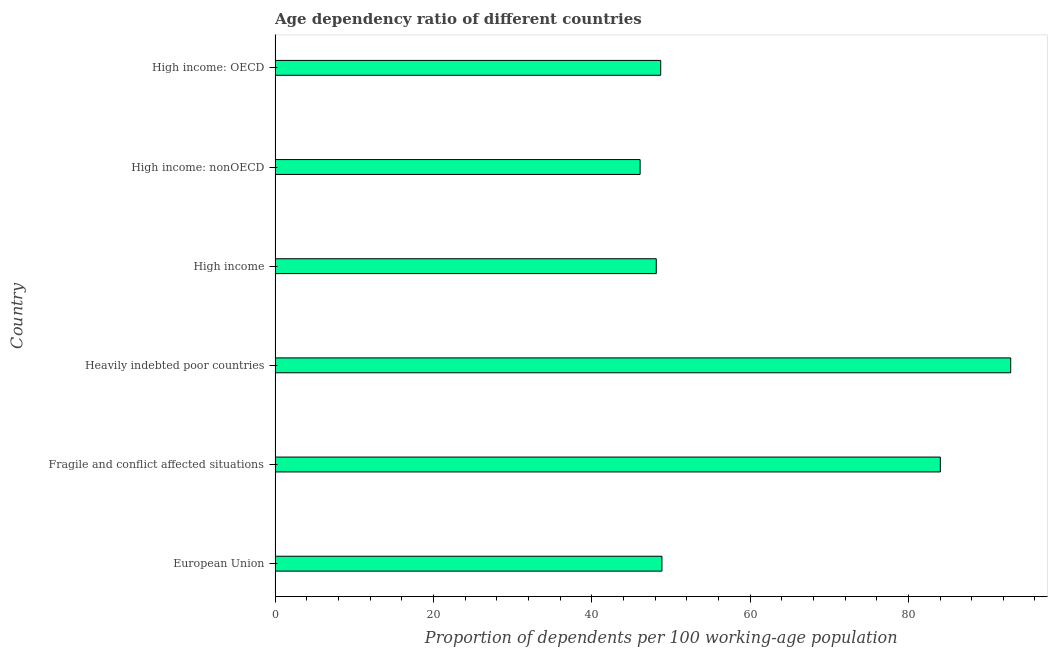Does the graph contain any zero values?
Make the answer very short. No. What is the title of the graph?
Provide a succinct answer. Age dependency ratio of different countries. What is the label or title of the X-axis?
Your answer should be very brief. Proportion of dependents per 100 working-age population. What is the label or title of the Y-axis?
Give a very brief answer. Country. What is the age dependency ratio in European Union?
Your answer should be compact. 48.87. Across all countries, what is the maximum age dependency ratio?
Make the answer very short. 92.93. Across all countries, what is the minimum age dependency ratio?
Make the answer very short. 46.12. In which country was the age dependency ratio maximum?
Keep it short and to the point. Heavily indebted poor countries. In which country was the age dependency ratio minimum?
Provide a short and direct response. High income: nonOECD. What is the sum of the age dependency ratio?
Ensure brevity in your answer.  368.84. What is the difference between the age dependency ratio in Fragile and conflict affected situations and High income?
Make the answer very short. 35.89. What is the average age dependency ratio per country?
Your answer should be compact. 61.47. What is the median age dependency ratio?
Ensure brevity in your answer.  48.79. What is the ratio of the age dependency ratio in European Union to that in Fragile and conflict affected situations?
Your response must be concise. 0.58. Is the age dependency ratio in High income: OECD less than that in High income: nonOECD?
Give a very brief answer. No. What is the difference between the highest and the second highest age dependency ratio?
Give a very brief answer. 8.89. Is the sum of the age dependency ratio in Fragile and conflict affected situations and High income greater than the maximum age dependency ratio across all countries?
Make the answer very short. Yes. What is the difference between the highest and the lowest age dependency ratio?
Provide a succinct answer. 46.82. Are all the bars in the graph horizontal?
Your answer should be compact. Yes. Are the values on the major ticks of X-axis written in scientific E-notation?
Provide a succinct answer. No. What is the Proportion of dependents per 100 working-age population of European Union?
Your answer should be very brief. 48.87. What is the Proportion of dependents per 100 working-age population of Fragile and conflict affected situations?
Give a very brief answer. 84.04. What is the Proportion of dependents per 100 working-age population of Heavily indebted poor countries?
Give a very brief answer. 92.93. What is the Proportion of dependents per 100 working-age population in High income?
Offer a terse response. 48.16. What is the Proportion of dependents per 100 working-age population in High income: nonOECD?
Make the answer very short. 46.12. What is the Proportion of dependents per 100 working-age population of High income: OECD?
Provide a short and direct response. 48.72. What is the difference between the Proportion of dependents per 100 working-age population in European Union and Fragile and conflict affected situations?
Keep it short and to the point. -35.17. What is the difference between the Proportion of dependents per 100 working-age population in European Union and Heavily indebted poor countries?
Offer a terse response. -44.06. What is the difference between the Proportion of dependents per 100 working-age population in European Union and High income?
Offer a terse response. 0.72. What is the difference between the Proportion of dependents per 100 working-age population in European Union and High income: nonOECD?
Offer a terse response. 2.76. What is the difference between the Proportion of dependents per 100 working-age population in European Union and High income: OECD?
Your response must be concise. 0.16. What is the difference between the Proportion of dependents per 100 working-age population in Fragile and conflict affected situations and Heavily indebted poor countries?
Make the answer very short. -8.89. What is the difference between the Proportion of dependents per 100 working-age population in Fragile and conflict affected situations and High income?
Offer a very short reply. 35.89. What is the difference between the Proportion of dependents per 100 working-age population in Fragile and conflict affected situations and High income: nonOECD?
Offer a very short reply. 37.93. What is the difference between the Proportion of dependents per 100 working-age population in Fragile and conflict affected situations and High income: OECD?
Give a very brief answer. 35.33. What is the difference between the Proportion of dependents per 100 working-age population in Heavily indebted poor countries and High income?
Offer a very short reply. 44.78. What is the difference between the Proportion of dependents per 100 working-age population in Heavily indebted poor countries and High income: nonOECD?
Your answer should be compact. 46.82. What is the difference between the Proportion of dependents per 100 working-age population in Heavily indebted poor countries and High income: OECD?
Offer a very short reply. 44.22. What is the difference between the Proportion of dependents per 100 working-age population in High income and High income: nonOECD?
Offer a terse response. 2.04. What is the difference between the Proportion of dependents per 100 working-age population in High income and High income: OECD?
Offer a terse response. -0.56. What is the difference between the Proportion of dependents per 100 working-age population in High income: nonOECD and High income: OECD?
Ensure brevity in your answer.  -2.6. What is the ratio of the Proportion of dependents per 100 working-age population in European Union to that in Fragile and conflict affected situations?
Make the answer very short. 0.58. What is the ratio of the Proportion of dependents per 100 working-age population in European Union to that in Heavily indebted poor countries?
Keep it short and to the point. 0.53. What is the ratio of the Proportion of dependents per 100 working-age population in European Union to that in High income: nonOECD?
Your answer should be very brief. 1.06. What is the ratio of the Proportion of dependents per 100 working-age population in European Union to that in High income: OECD?
Your response must be concise. 1. What is the ratio of the Proportion of dependents per 100 working-age population in Fragile and conflict affected situations to that in Heavily indebted poor countries?
Your answer should be very brief. 0.9. What is the ratio of the Proportion of dependents per 100 working-age population in Fragile and conflict affected situations to that in High income?
Ensure brevity in your answer.  1.75. What is the ratio of the Proportion of dependents per 100 working-age population in Fragile and conflict affected situations to that in High income: nonOECD?
Ensure brevity in your answer.  1.82. What is the ratio of the Proportion of dependents per 100 working-age population in Fragile and conflict affected situations to that in High income: OECD?
Ensure brevity in your answer.  1.73. What is the ratio of the Proportion of dependents per 100 working-age population in Heavily indebted poor countries to that in High income?
Provide a succinct answer. 1.93. What is the ratio of the Proportion of dependents per 100 working-age population in Heavily indebted poor countries to that in High income: nonOECD?
Provide a succinct answer. 2.02. What is the ratio of the Proportion of dependents per 100 working-age population in Heavily indebted poor countries to that in High income: OECD?
Your answer should be compact. 1.91. What is the ratio of the Proportion of dependents per 100 working-age population in High income to that in High income: nonOECD?
Your answer should be compact. 1.04. What is the ratio of the Proportion of dependents per 100 working-age population in High income to that in High income: OECD?
Make the answer very short. 0.99. What is the ratio of the Proportion of dependents per 100 working-age population in High income: nonOECD to that in High income: OECD?
Your answer should be compact. 0.95. 